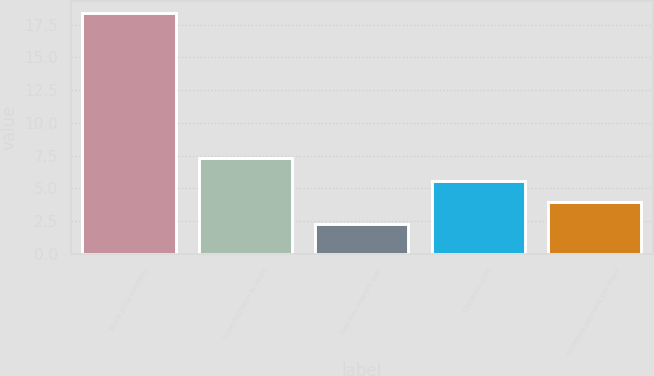<chart> <loc_0><loc_0><loc_500><loc_500><bar_chart><fcel>Stock price volatility<fcel>Expected term in years<fcel>Risk-free interest rate<fcel>Dividend yield<fcel>Dividend payment per share<nl><fcel>18.39<fcel>7.35<fcel>2.31<fcel>5.53<fcel>3.92<nl></chart> 